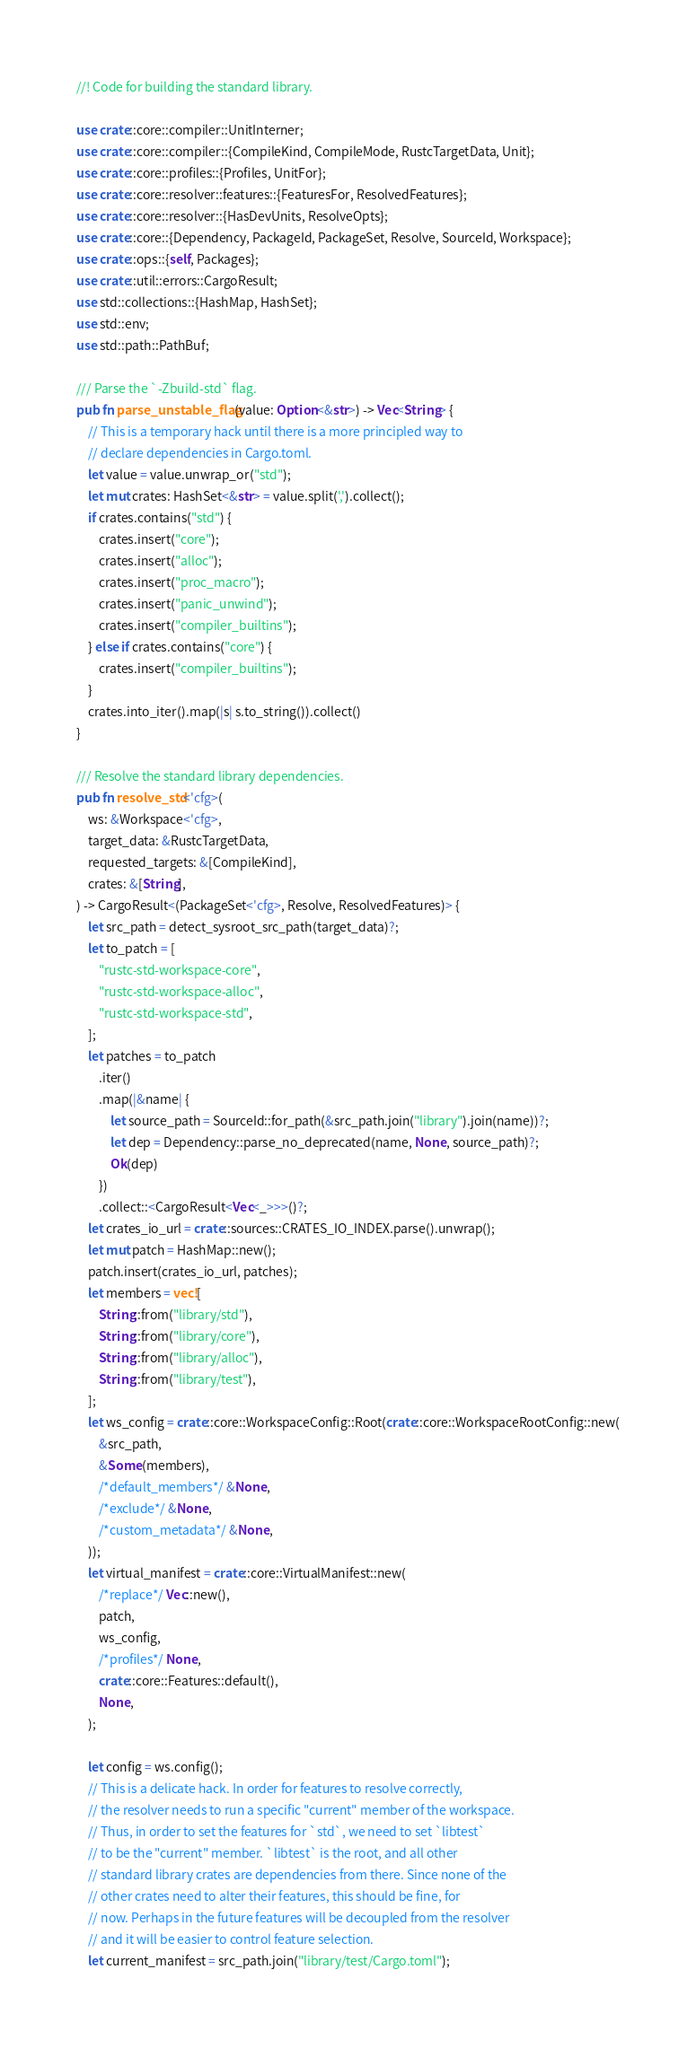Convert code to text. <code><loc_0><loc_0><loc_500><loc_500><_Rust_>//! Code for building the standard library.

use crate::core::compiler::UnitInterner;
use crate::core::compiler::{CompileKind, CompileMode, RustcTargetData, Unit};
use crate::core::profiles::{Profiles, UnitFor};
use crate::core::resolver::features::{FeaturesFor, ResolvedFeatures};
use crate::core::resolver::{HasDevUnits, ResolveOpts};
use crate::core::{Dependency, PackageId, PackageSet, Resolve, SourceId, Workspace};
use crate::ops::{self, Packages};
use crate::util::errors::CargoResult;
use std::collections::{HashMap, HashSet};
use std::env;
use std::path::PathBuf;

/// Parse the `-Zbuild-std` flag.
pub fn parse_unstable_flag(value: Option<&str>) -> Vec<String> {
    // This is a temporary hack until there is a more principled way to
    // declare dependencies in Cargo.toml.
    let value = value.unwrap_or("std");
    let mut crates: HashSet<&str> = value.split(',').collect();
    if crates.contains("std") {
        crates.insert("core");
        crates.insert("alloc");
        crates.insert("proc_macro");
        crates.insert("panic_unwind");
        crates.insert("compiler_builtins");
    } else if crates.contains("core") {
        crates.insert("compiler_builtins");
    }
    crates.into_iter().map(|s| s.to_string()).collect()
}

/// Resolve the standard library dependencies.
pub fn resolve_std<'cfg>(
    ws: &Workspace<'cfg>,
    target_data: &RustcTargetData,
    requested_targets: &[CompileKind],
    crates: &[String],
) -> CargoResult<(PackageSet<'cfg>, Resolve, ResolvedFeatures)> {
    let src_path = detect_sysroot_src_path(target_data)?;
    let to_patch = [
        "rustc-std-workspace-core",
        "rustc-std-workspace-alloc",
        "rustc-std-workspace-std",
    ];
    let patches = to_patch
        .iter()
        .map(|&name| {
            let source_path = SourceId::for_path(&src_path.join("library").join(name))?;
            let dep = Dependency::parse_no_deprecated(name, None, source_path)?;
            Ok(dep)
        })
        .collect::<CargoResult<Vec<_>>>()?;
    let crates_io_url = crate::sources::CRATES_IO_INDEX.parse().unwrap();
    let mut patch = HashMap::new();
    patch.insert(crates_io_url, patches);
    let members = vec![
        String::from("library/std"),
        String::from("library/core"),
        String::from("library/alloc"),
        String::from("library/test"),
    ];
    let ws_config = crate::core::WorkspaceConfig::Root(crate::core::WorkspaceRootConfig::new(
        &src_path,
        &Some(members),
        /*default_members*/ &None,
        /*exclude*/ &None,
        /*custom_metadata*/ &None,
    ));
    let virtual_manifest = crate::core::VirtualManifest::new(
        /*replace*/ Vec::new(),
        patch,
        ws_config,
        /*profiles*/ None,
        crate::core::Features::default(),
        None,
    );

    let config = ws.config();
    // This is a delicate hack. In order for features to resolve correctly,
    // the resolver needs to run a specific "current" member of the workspace.
    // Thus, in order to set the features for `std`, we need to set `libtest`
    // to be the "current" member. `libtest` is the root, and all other
    // standard library crates are dependencies from there. Since none of the
    // other crates need to alter their features, this should be fine, for
    // now. Perhaps in the future features will be decoupled from the resolver
    // and it will be easier to control feature selection.
    let current_manifest = src_path.join("library/test/Cargo.toml");</code> 